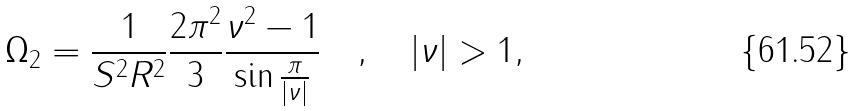<formula> <loc_0><loc_0><loc_500><loc_500>\Omega _ { 2 } = \frac { 1 } { S ^ { 2 } R ^ { 2 } } \frac { 2 \pi ^ { 2 } } { 3 } \frac { \nu ^ { 2 } - 1 } { \sin \frac { \pi } { | \nu | } } \quad , \quad | \nu | > 1 ,</formula> 